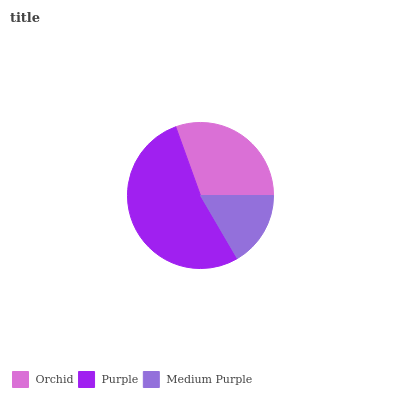Is Medium Purple the minimum?
Answer yes or no. Yes. Is Purple the maximum?
Answer yes or no. Yes. Is Purple the minimum?
Answer yes or no. No. Is Medium Purple the maximum?
Answer yes or no. No. Is Purple greater than Medium Purple?
Answer yes or no. Yes. Is Medium Purple less than Purple?
Answer yes or no. Yes. Is Medium Purple greater than Purple?
Answer yes or no. No. Is Purple less than Medium Purple?
Answer yes or no. No. Is Orchid the high median?
Answer yes or no. Yes. Is Orchid the low median?
Answer yes or no. Yes. Is Medium Purple the high median?
Answer yes or no. No. Is Purple the low median?
Answer yes or no. No. 